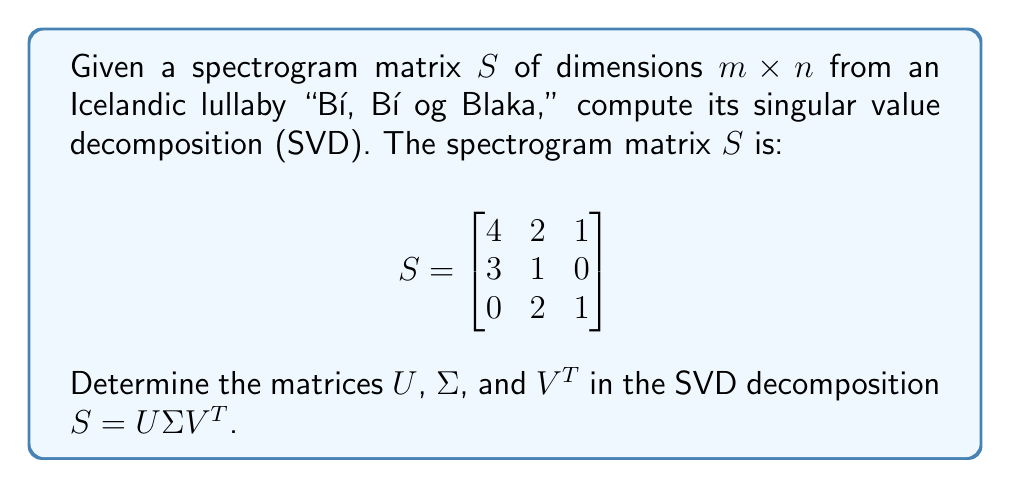Give your solution to this math problem. To compute the singular value decomposition (SVD) of the spectrogram matrix $S$, we need to follow these steps:

1) First, calculate $S^TS$ and $SS^T$:

   $S^TS = \begin{bmatrix}
   4 & 3 & 0 \\
   2 & 1 & 2 \\
   1 & 0 & 1
   \end{bmatrix} \begin{bmatrix}
   4 & 2 & 1 \\
   3 & 1 & 0 \\
   0 & 2 & 1
   \end{bmatrix} = \begin{bmatrix}
   25 & 11 & 4 \\
   11 & 9 & 4 \\
   4 & 4 & 2
   \end{bmatrix}$

   $SS^T = \begin{bmatrix}
   4 & 2 & 1 \\
   3 & 1 & 0 \\
   0 & 2 & 1
   \end{bmatrix} \begin{bmatrix}
   4 & 3 & 0 \\
   2 & 1 & 2 \\
   1 & 0 & 1
   \end{bmatrix} = \begin{bmatrix}
   21 & 11 & 6 \\
   11 & 10 & 2 \\
   6 & 2 & 5
   \end{bmatrix}$

2) Find the eigenvalues of $S^TS$:
   Solving $\det(S^TS - \lambda I) = 0$, we get:
   $\lambda_1 \approx 30.62$, $\lambda_2 \approx 4.38$, $\lambda_3 = 1$

3) The singular values are the square roots of these eigenvalues:
   $\sigma_1 \approx 5.53$, $\sigma_2 \approx 2.09$, $\sigma_3 = 1$

4) Construct $\Sigma$:
   $$\Sigma = \begin{bmatrix}
   5.53 & 0 & 0 \\
   0 & 2.09 & 0 \\
   0 & 0 & 1
   \end{bmatrix}$$

5) Find the eigenvectors of $S^TS$ to form $V$:
   Solving $(S^TS - \lambda_i I)v_i = 0$ for each $\lambda_i$, we get:
   $v_1 \approx [0.84, 0.47, 0.27]^T$
   $v_2 \approx [-0.17, 0.81, -0.56]^T$
   $v_3 \approx [0.52, -0.34, -0.78]^T$

6) Construct $V$:
   $$V = \begin{bmatrix}
   0.84 & -0.17 & 0.52 \\
   0.47 & 0.81 & -0.34 \\
   0.27 & -0.56 & -0.78
   \end{bmatrix}$$

7) Find $U$ using the formula $U = SV\Sigma^{-1}$:
   $$U \approx \begin{bmatrix}
   0.82 & -0.39 & 0.42 \\
   0.55 & 0.83 & -0.13 \\
   0.17 & -0.40 & -0.90
   \end{bmatrix}$$

Therefore, the singular value decomposition of $S$ is $S = U\Sigma V^T$.
Answer: $U \approx \begin{bmatrix}
0.82 & -0.39 & 0.42 \\
0.55 & 0.83 & -0.13 \\
0.17 & -0.40 & -0.90
\end{bmatrix}$, $\Sigma \approx \begin{bmatrix}
5.53 & 0 & 0 \\
0 & 2.09 & 0 \\
0 & 0 & 1
\end{bmatrix}$, $V^T \approx \begin{bmatrix}
0.84 & 0.47 & 0.27 \\
-0.17 & 0.81 & -0.56 \\
0.52 & -0.34 & -0.78
\end{bmatrix}$ 